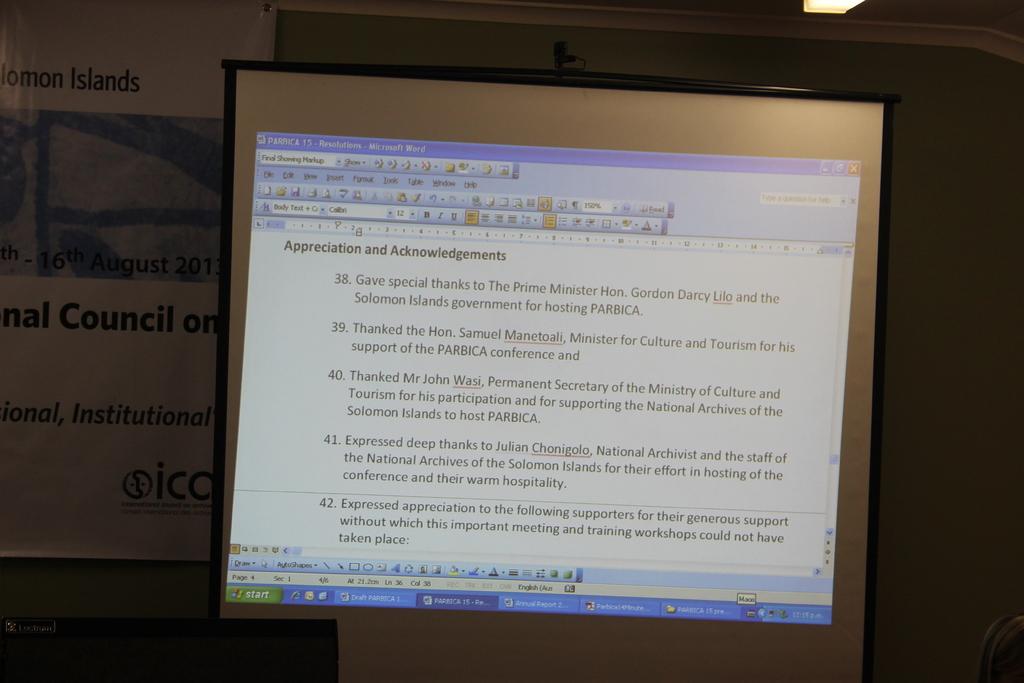What does item 38 thank the government for?
Make the answer very short. For hosting parbica. What is the subtitle shown?
Provide a short and direct response. Appreciation and acknowledgements. 